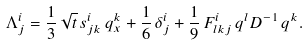<formula> <loc_0><loc_0><loc_500><loc_500>\Lambda ^ { i } _ { j } = { \frac { 1 } { 3 } } \, \sqrt { t } \, s ^ { i } _ { j k } \, q ^ { k } _ { x } + { \frac { 1 } { 6 } } \, \delta ^ { i } _ { j } + { \frac { 1 } { 9 } } \, F ^ { i } _ { l k j } \, q ^ { l } D ^ { - 1 } \, q ^ { k } .</formula> 